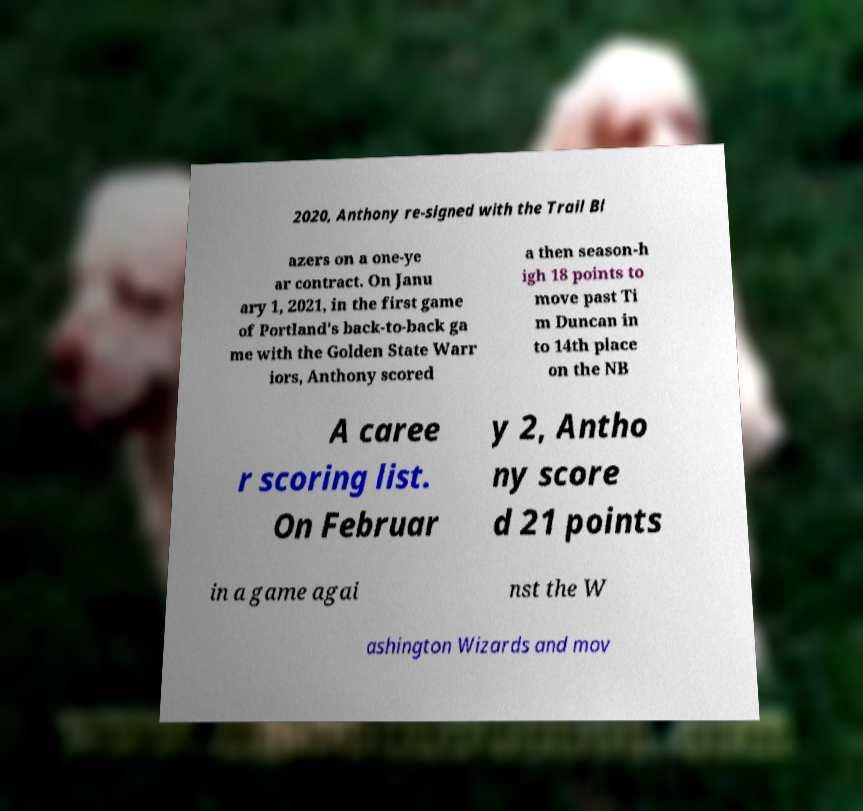I need the written content from this picture converted into text. Can you do that? 2020, Anthony re-signed with the Trail Bl azers on a one-ye ar contract. On Janu ary 1, 2021, in the first game of Portland's back-to-back ga me with the Golden State Warr iors, Anthony scored a then season-h igh 18 points to move past Ti m Duncan in to 14th place on the NB A caree r scoring list. On Februar y 2, Antho ny score d 21 points in a game agai nst the W ashington Wizards and mov 